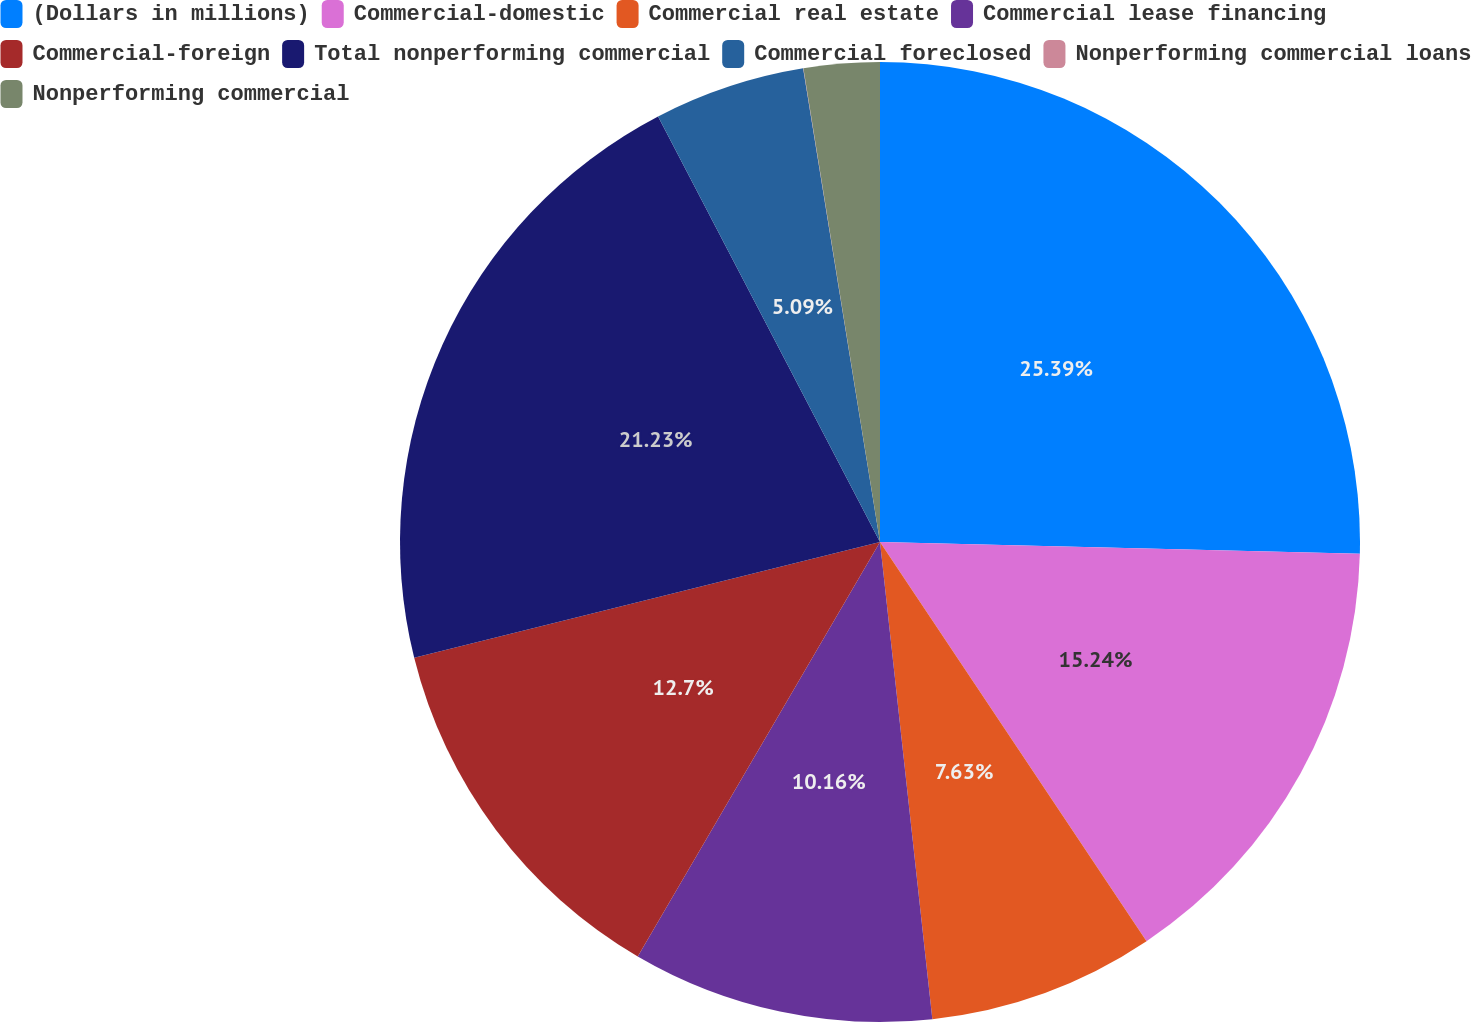Convert chart. <chart><loc_0><loc_0><loc_500><loc_500><pie_chart><fcel>(Dollars in millions)<fcel>Commercial-domestic<fcel>Commercial real estate<fcel>Commercial lease financing<fcel>Commercial-foreign<fcel>Total nonperforming commercial<fcel>Commercial foreclosed<fcel>Nonperforming commercial loans<fcel>Nonperforming commercial<nl><fcel>25.39%<fcel>15.24%<fcel>7.63%<fcel>10.16%<fcel>12.7%<fcel>21.23%<fcel>5.09%<fcel>0.01%<fcel>2.55%<nl></chart> 